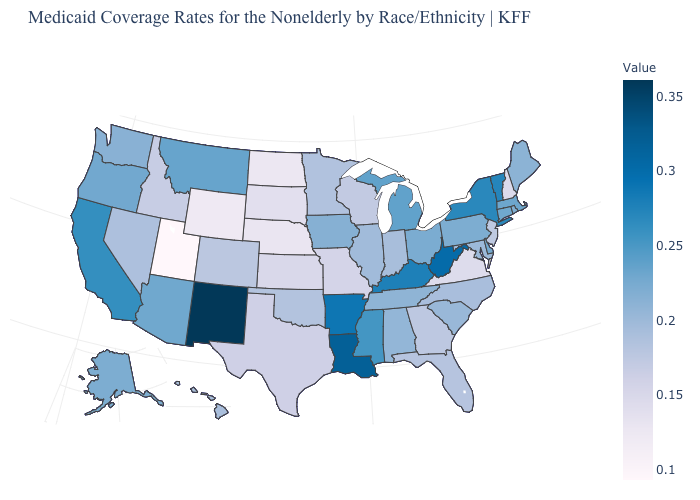Among the states that border Idaho , which have the lowest value?
Quick response, please. Utah. Which states have the lowest value in the USA?
Write a very short answer. Utah. Does New Mexico have the highest value in the USA?
Concise answer only. Yes. Among the states that border North Dakota , does South Dakota have the highest value?
Keep it brief. No. 